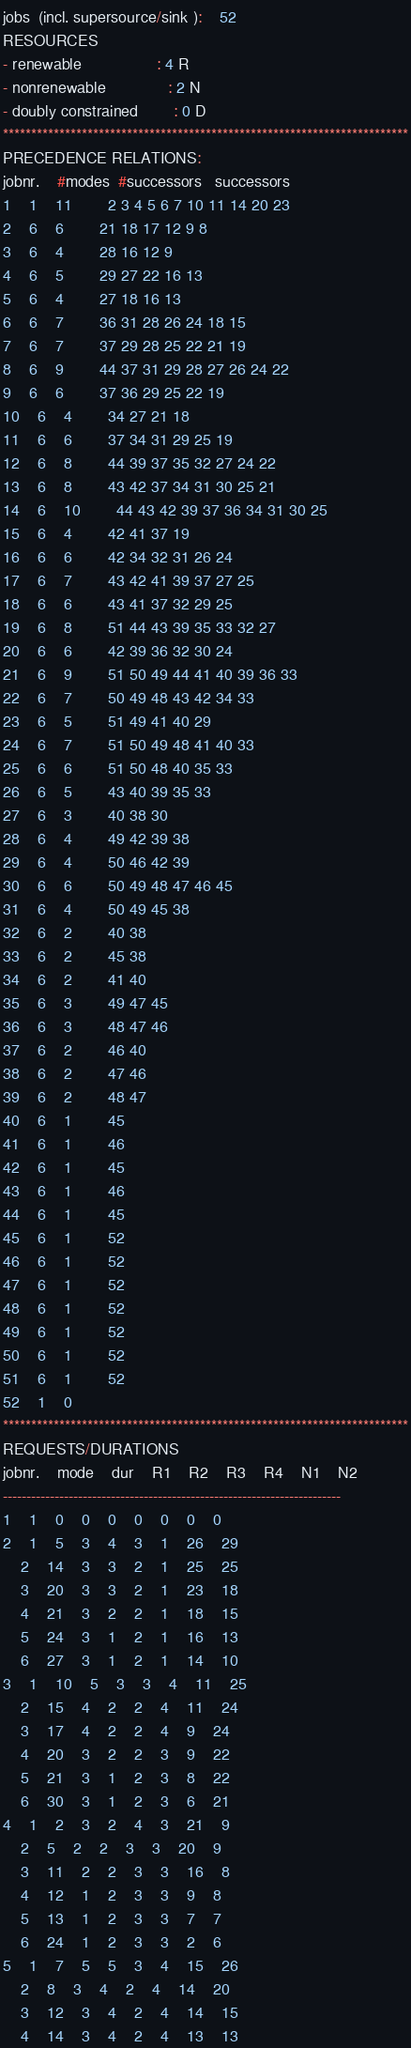Convert code to text. <code><loc_0><loc_0><loc_500><loc_500><_ObjectiveC_>jobs  (incl. supersource/sink ):	52
RESOURCES
- renewable                 : 4 R
- nonrenewable              : 2 N
- doubly constrained        : 0 D
************************************************************************
PRECEDENCE RELATIONS:
jobnr.    #modes  #successors   successors
1	1	11		2 3 4 5 6 7 10 11 14 20 23 
2	6	6		21 18 17 12 9 8 
3	6	4		28 16 12 9 
4	6	5		29 27 22 16 13 
5	6	4		27 18 16 13 
6	6	7		36 31 28 26 24 18 15 
7	6	7		37 29 28 25 22 21 19 
8	6	9		44 37 31 29 28 27 26 24 22 
9	6	6		37 36 29 25 22 19 
10	6	4		34 27 21 18 
11	6	6		37 34 31 29 25 19 
12	6	8		44 39 37 35 32 27 24 22 
13	6	8		43 42 37 34 31 30 25 21 
14	6	10		44 43 42 39 37 36 34 31 30 25 
15	6	4		42 41 37 19 
16	6	6		42 34 32 31 26 24 
17	6	7		43 42 41 39 37 27 25 
18	6	6		43 41 37 32 29 25 
19	6	8		51 44 43 39 35 33 32 27 
20	6	6		42 39 36 32 30 24 
21	6	9		51 50 49 44 41 40 39 36 33 
22	6	7		50 49 48 43 42 34 33 
23	6	5		51 49 41 40 29 
24	6	7		51 50 49 48 41 40 33 
25	6	6		51 50 48 40 35 33 
26	6	5		43 40 39 35 33 
27	6	3		40 38 30 
28	6	4		49 42 39 38 
29	6	4		50 46 42 39 
30	6	6		50 49 48 47 46 45 
31	6	4		50 49 45 38 
32	6	2		40 38 
33	6	2		45 38 
34	6	2		41 40 
35	6	3		49 47 45 
36	6	3		48 47 46 
37	6	2		46 40 
38	6	2		47 46 
39	6	2		48 47 
40	6	1		45 
41	6	1		46 
42	6	1		45 
43	6	1		46 
44	6	1		45 
45	6	1		52 
46	6	1		52 
47	6	1		52 
48	6	1		52 
49	6	1		52 
50	6	1		52 
51	6	1		52 
52	1	0		
************************************************************************
REQUESTS/DURATIONS
jobnr.	mode	dur	R1	R2	R3	R4	N1	N2	
------------------------------------------------------------------------
1	1	0	0	0	0	0	0	0	
2	1	5	3	4	3	1	26	29	
	2	14	3	3	2	1	25	25	
	3	20	3	3	2	1	23	18	
	4	21	3	2	2	1	18	15	
	5	24	3	1	2	1	16	13	
	6	27	3	1	2	1	14	10	
3	1	10	5	3	3	4	11	25	
	2	15	4	2	2	4	11	24	
	3	17	4	2	2	4	9	24	
	4	20	3	2	2	3	9	22	
	5	21	3	1	2	3	8	22	
	6	30	3	1	2	3	6	21	
4	1	2	3	2	4	3	21	9	
	2	5	2	2	3	3	20	9	
	3	11	2	2	3	3	16	8	
	4	12	1	2	3	3	9	8	
	5	13	1	2	3	3	7	7	
	6	24	1	2	3	3	2	6	
5	1	7	5	5	3	4	15	26	
	2	8	3	4	2	4	14	20	
	3	12	3	4	2	4	14	15	
	4	14	3	4	2	4	13	13	</code> 